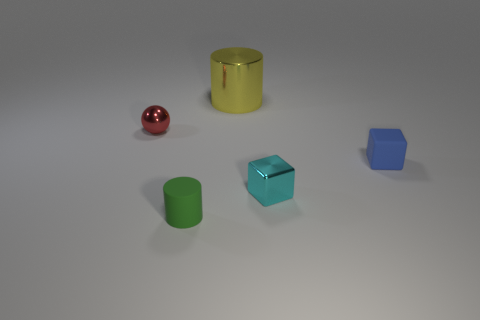Add 2 blue cubes. How many objects exist? 7 Subtract all cylinders. How many objects are left? 3 Subtract all tiny rubber things. Subtract all large metal objects. How many objects are left? 2 Add 4 small cylinders. How many small cylinders are left? 5 Add 5 shiny things. How many shiny things exist? 8 Subtract 0 cyan spheres. How many objects are left? 5 